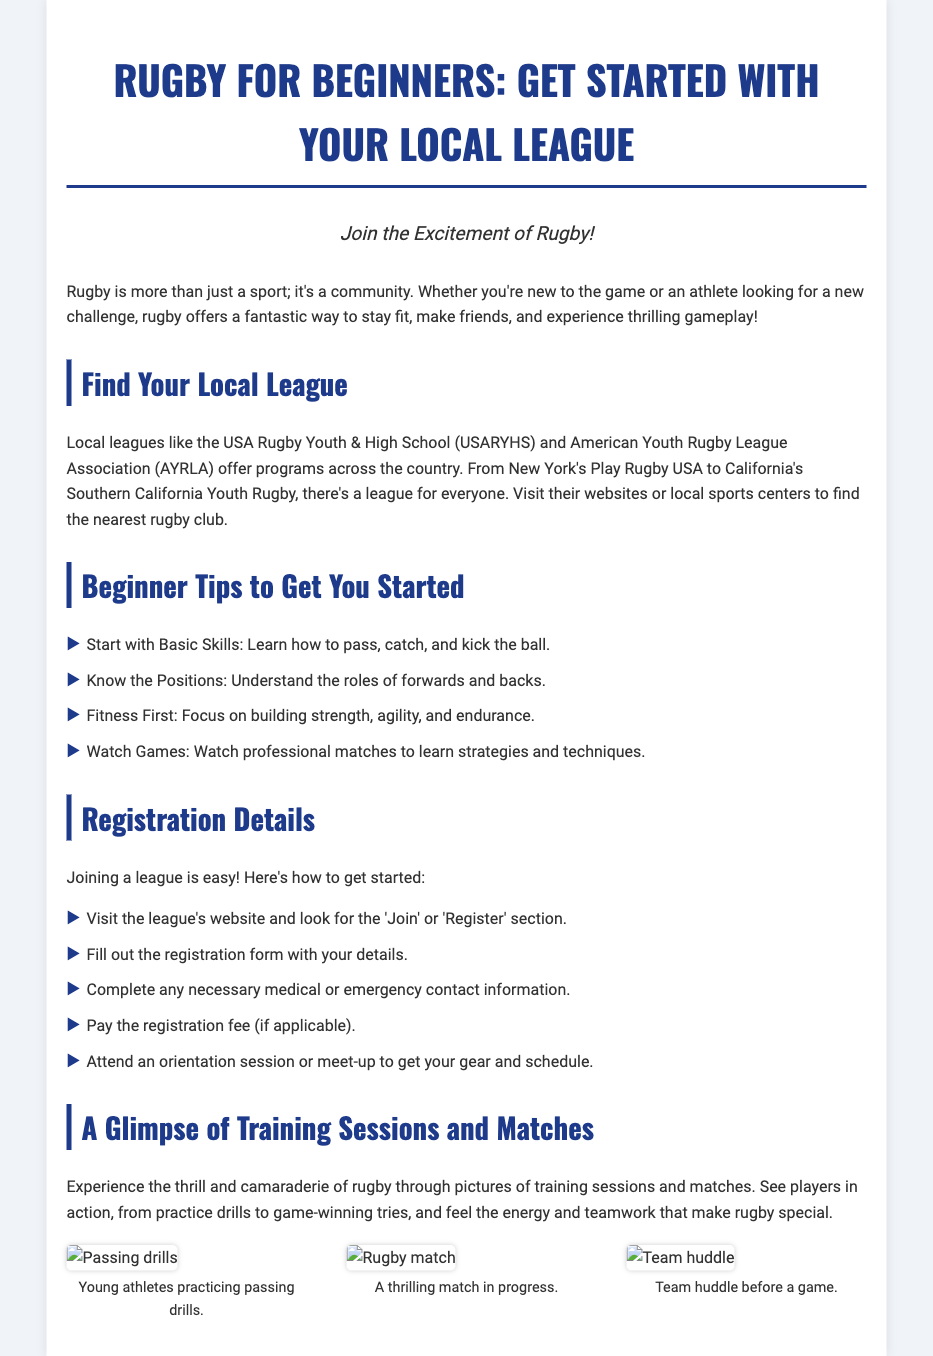What are the two local leagues mentioned? The local leagues mentioned are the USA Rugby Youth & High School and American Youth Rugby League Association.
Answer: USARYHS and AYRLA What should you learn first as a beginner? The document advises beginners to start with basic skills like passing, catching, and kicking the ball.
Answer: Basic skills How many steps are outlined for registration? The document provides five steps for registration.
Answer: Five What type of pictures are included in the document? The document includes pictures of training sessions and matches.
Answer: Training sessions and matches What kind of fitness should beginners focus on? The document emphasizes building strength, agility, and endurance for beginners.
Answer: Strength, agility, and endurance What does the registration process require after filling out the form? After filling out the form, completing any necessary medical or emergency contact information is required.
Answer: Medical or emergency contact information What does the document suggest watching to learn strategies? The document suggests watching professional matches to learn strategies and techniques.
Answer: Professional matches What are players practicing in the first image? The first image shows young athletes practicing passing drills.
Answer: Passing drills 